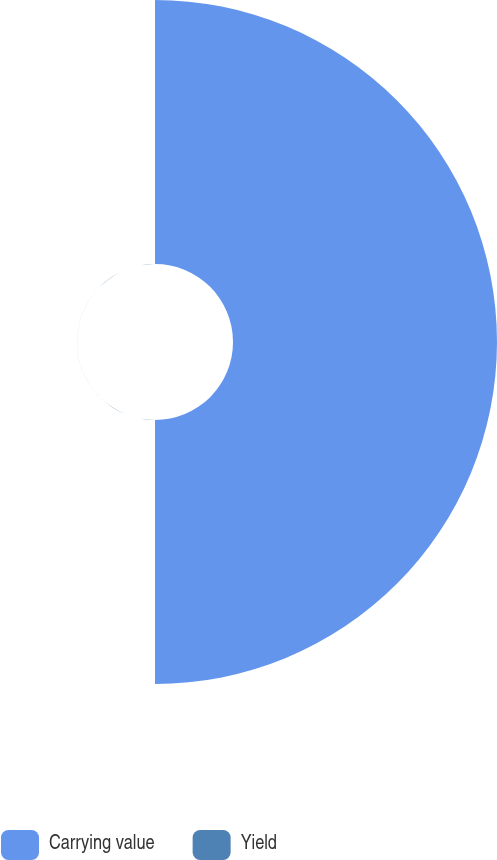Convert chart. <chart><loc_0><loc_0><loc_500><loc_500><pie_chart><fcel>Carrying value<fcel>Yield<nl><fcel>99.98%<fcel>0.02%<nl></chart> 